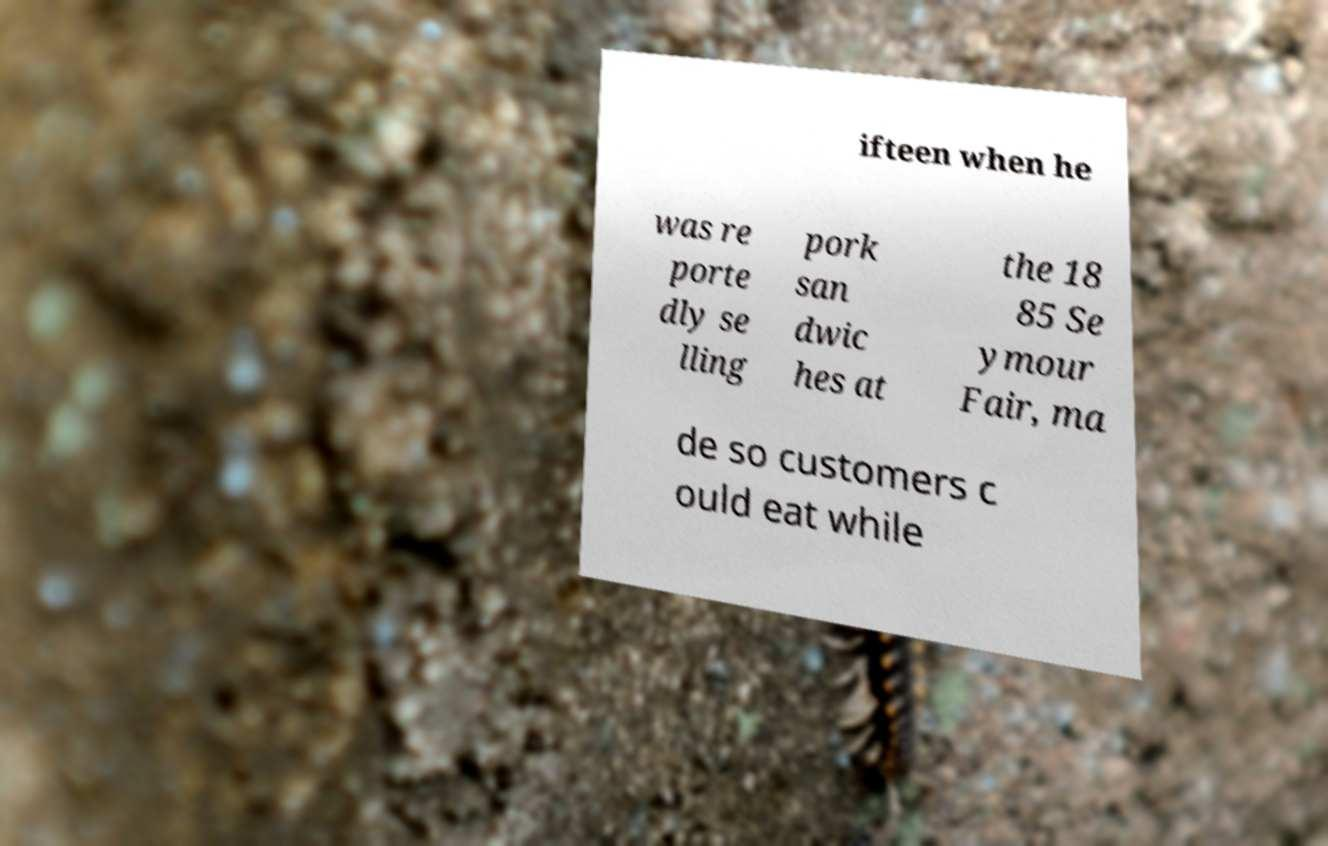Please read and relay the text visible in this image. What does it say? ifteen when he was re porte dly se lling pork san dwic hes at the 18 85 Se ymour Fair, ma de so customers c ould eat while 